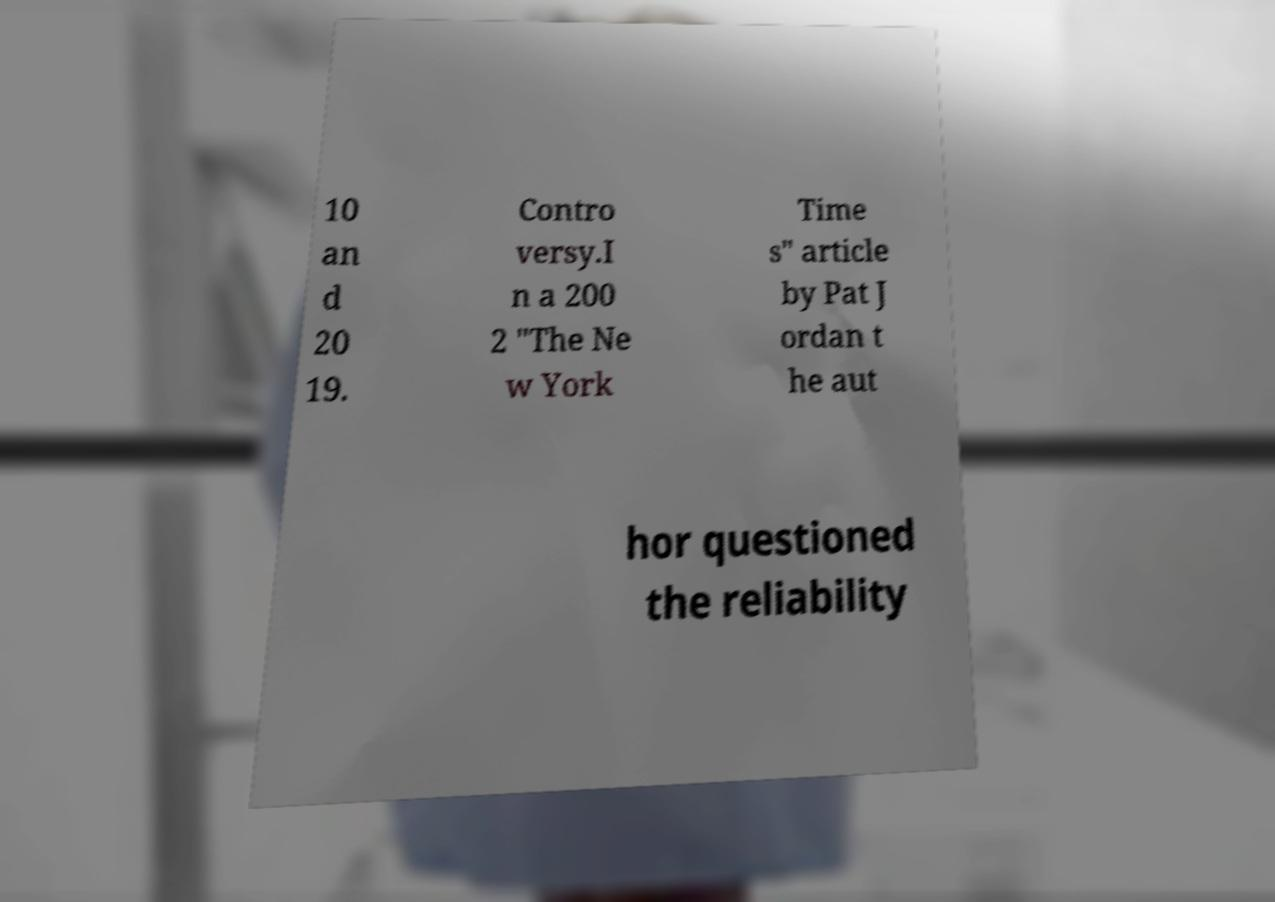Could you assist in decoding the text presented in this image and type it out clearly? 10 an d 20 19. Contro versy.I n a 200 2 "The Ne w York Time s" article by Pat J ordan t he aut hor questioned the reliability 